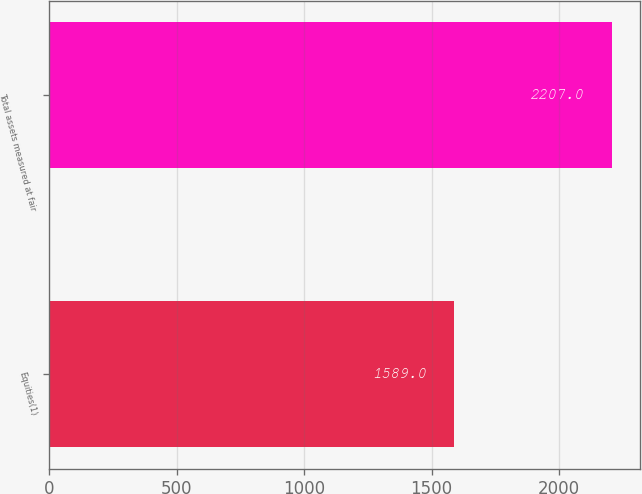Convert chart to OTSL. <chart><loc_0><loc_0><loc_500><loc_500><bar_chart><fcel>Equities(1)<fcel>Total assets measured at fair<nl><fcel>1589<fcel>2207<nl></chart> 